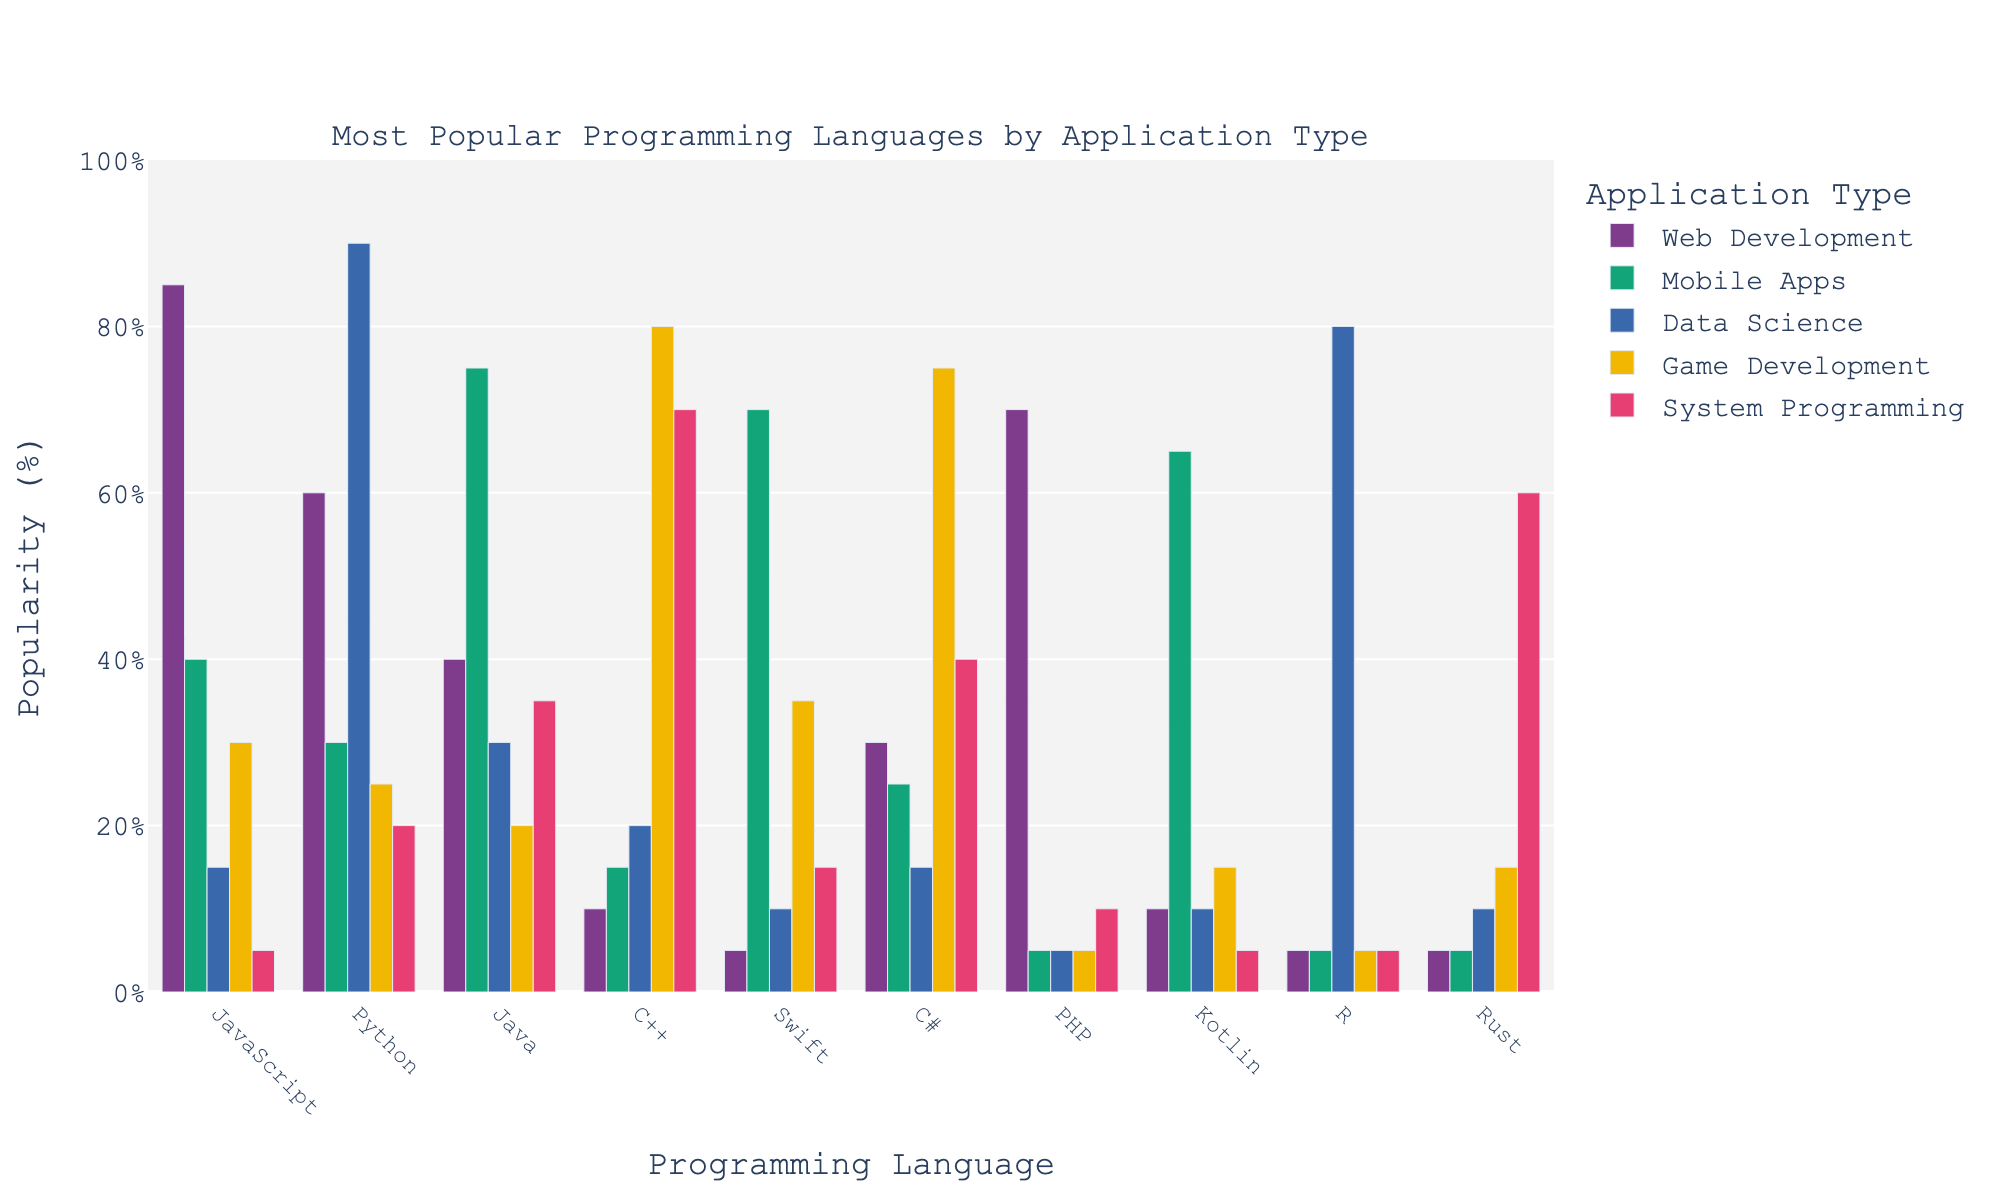Which programming language is the most popular for web development? Look at the bars in the web development category. The tallest bar represents the most popular language. JavaScript has the tallest bar.
Answer: JavaScript Which programming language has the highest popularity in data science? Look at the bars in the data science category. The tallest bar indicates the most popular language. Python has the tallest bar.
Answer: Python How many programming languages are more popular in game development than system programming? Compare the height of each bar for all languages in game development and system programming categories. Only C++ and C# have taller bars for game development than for system programming.
Answer: 2 Which application type has the least popularity for PHP? Inspect the PHP bars for each application type. The mobile apps, data science, and game development categories have a popularity of 5%, making them the least popular.
Answer: Mobile Apps, Data Science, and Game Development Which two programming languages are equally popular in mobile apps? Look at the bars in the mobile apps category. Identify which two bars have the same height. Swift and Kotlin both have bars reaching 70%.
Answer: Swift and Kotlin What is the difference in popularity between Java and Python for web development? Look at the heights of the Java and Python bars in the web development category. Java has a height of 40%, while Python has a height of 60%. The difference is 60% - 40%.
Answer: 20% What is the total popularity percentage for data science when combining Python and R? Add the heights of the Python and R bars for data science. Python has a height of 90% and R has a height of 80%. The total is 90% + 80%.
Answer: 170% Which programming language is more popular for system programming, Java or C++? Compare the heights of the Java and C++ bars in the system programming category. C++ has a height of 70%, while Java has a height of 35%.
Answer: C++ Which programming language has the lowest popularity in web development? Look at all the bars in the web development category to find the shortest one. Swift, R, and Rust all have the lowest bar at 5% each.
Answer: Swift, R, and Rust What is the average popularity of C# across all application types? Sum the popularity percentages of C# for each application type and divide by the number of application types (5). (30 + 25 + 15 + 75 + 40) / 5 = 185 / 5.
Answer: 37% 